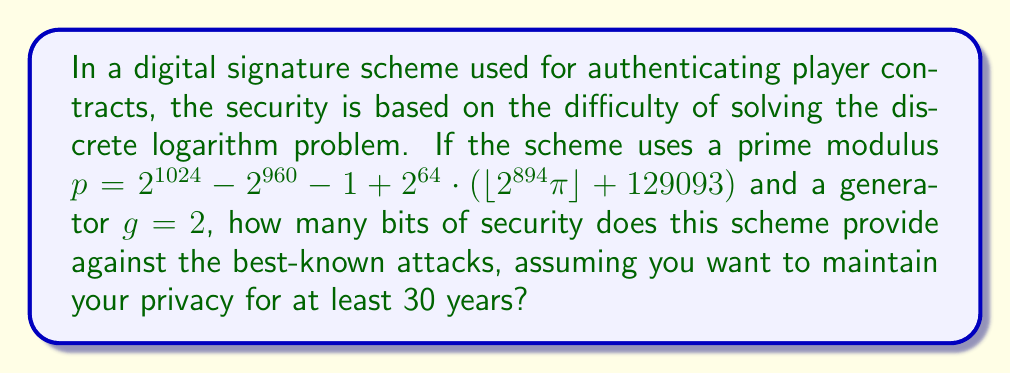Show me your answer to this math problem. To determine the bits of security for this digital signature scheme, we need to follow these steps:

1) The security of the scheme is based on the difficulty of the discrete logarithm problem in a finite field of size $p$.

2) The size of $p$ is approximately 1024 bits, as $p \approx 2^{1024}$.

3) For discrete logarithm problems in finite fields, the best known classical algorithm is the General Number Field Sieve (GNFS).

4) The complexity of GNFS for a prime $p$ of $n$ bits is:

   $$L_p[1/3, (64/9)^{1/3}] = \exp((64/9)^{1/3} \cdot (\ln p)^{1/3} \cdot (\ln \ln p)^{2/3})$$

5) This complexity is often approximated as $2^{c \cdot n^{1/3} \cdot (\ln n)^{2/3}}$, where $c \approx 1.923$.

6) For a 1024-bit prime, this gives us approximately $2^{86}$ operations.

7) Therefore, the security level is about 86 bits.

8) However, we need to consider future improvements in computing power. A common rule of thumb is to add 1 bit of security per year for long-term security.

9) For 30 years of security, we need to add 30 bits, bringing our total to 116 bits.

Therefore, this scheme provides approximately 116 bits of security for a 30-year timeframe.
Answer: 116 bits 